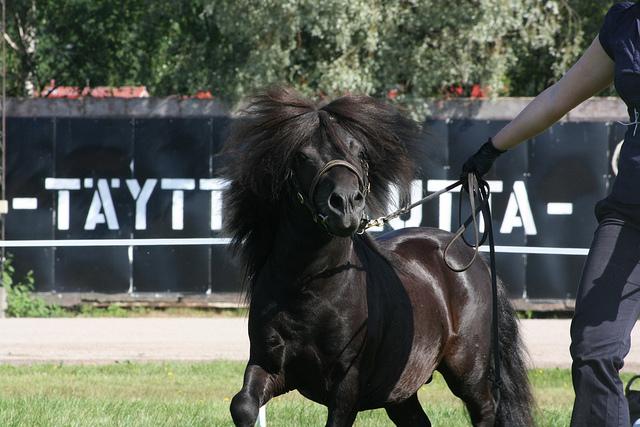Is this animal being lead?
Answer briefly. Yes. What color is the horse?
Answer briefly. Black. What color is the letters in the background?
Be succinct. White. 